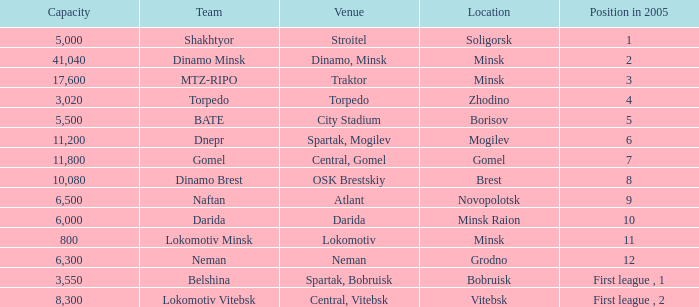Can you tell me the Capacity that has the Position in 2005 of 8? 10080.0. 